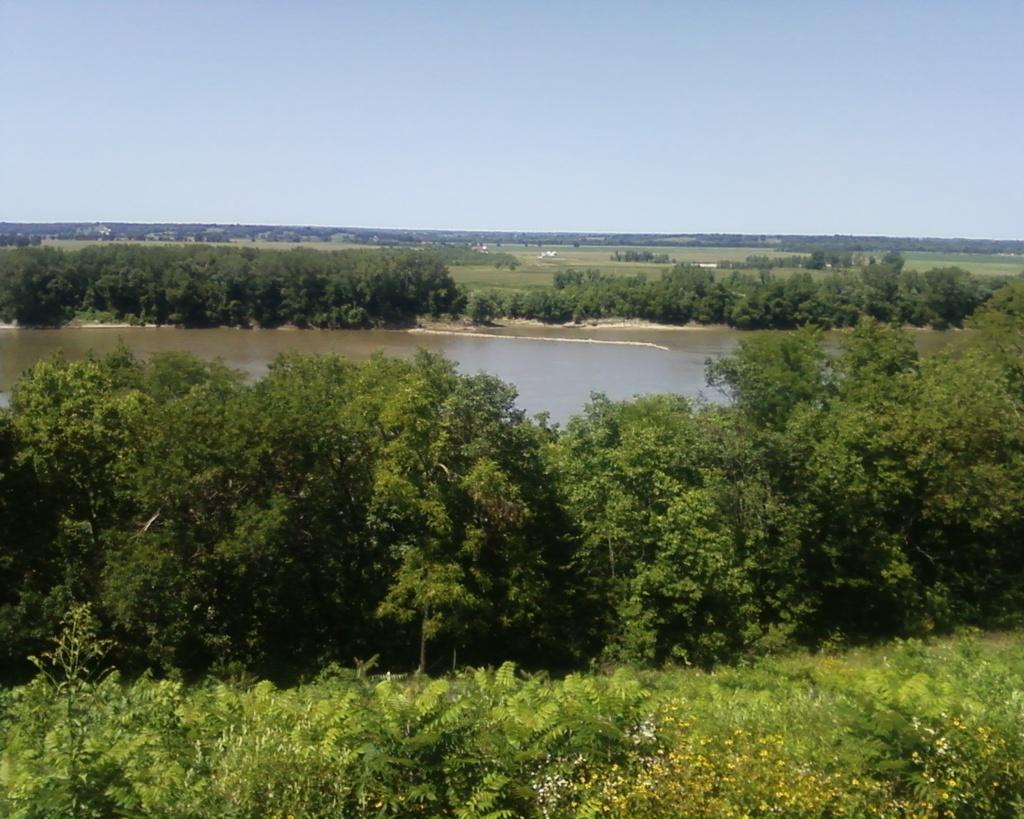What can be seen in the foreground area of the image? There are trees and water in the foreground area of the image. What is visible in the background area of the image? There is greenery and the sky in the background area of the image. How many boots can be seen in the image? There are no boots present in the image. What type of verse is being recited in the image? There is no verse or any indication of a recitation in the image. 